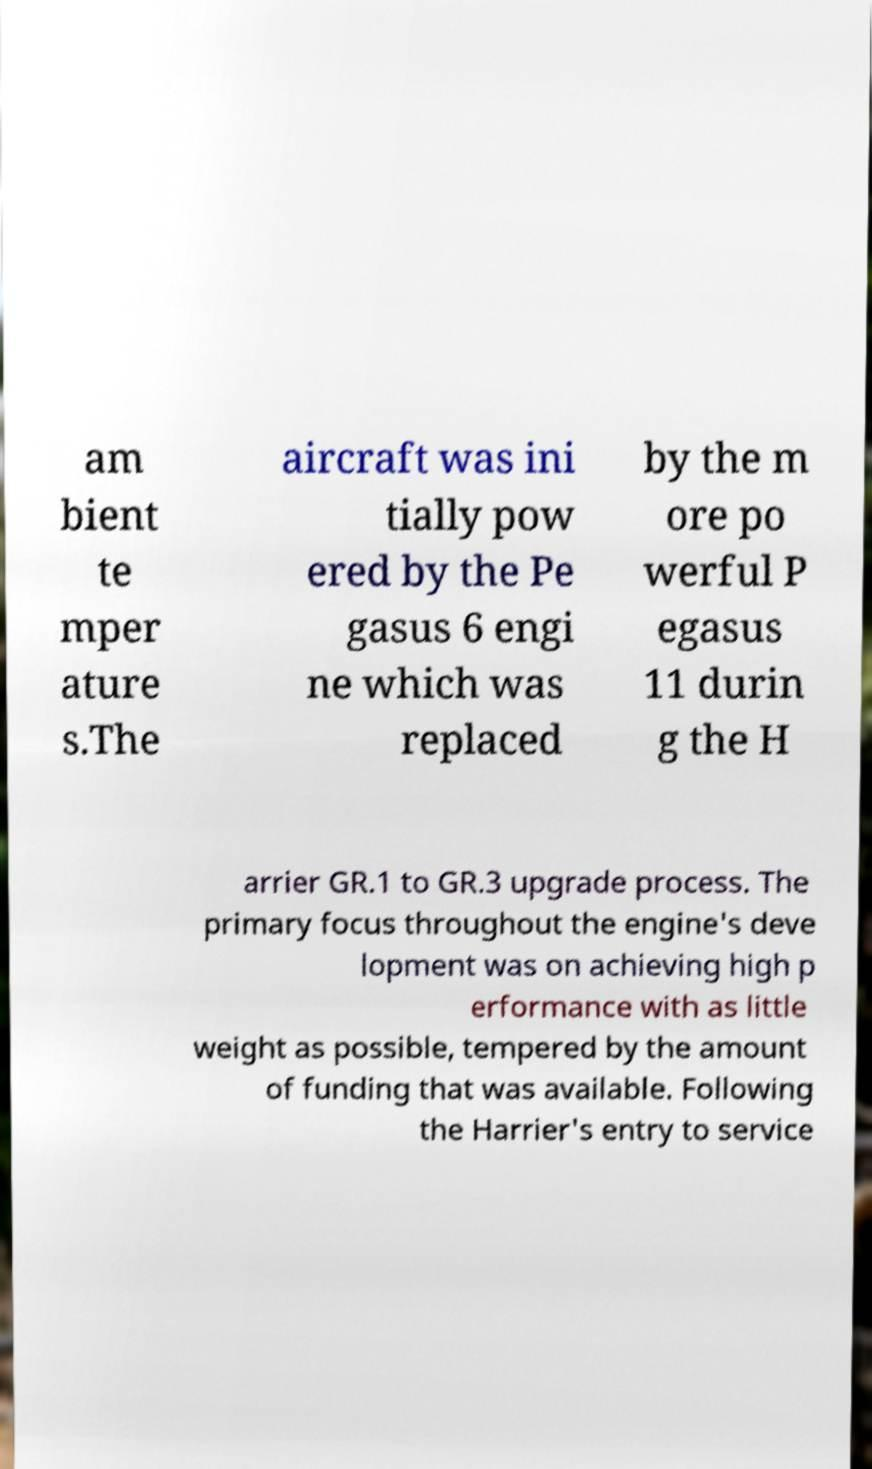Could you extract and type out the text from this image? am bient te mper ature s.The aircraft was ini tially pow ered by the Pe gasus 6 engi ne which was replaced by the m ore po werful P egasus 11 durin g the H arrier GR.1 to GR.3 upgrade process. The primary focus throughout the engine's deve lopment was on achieving high p erformance with as little weight as possible, tempered by the amount of funding that was available. Following the Harrier's entry to service 